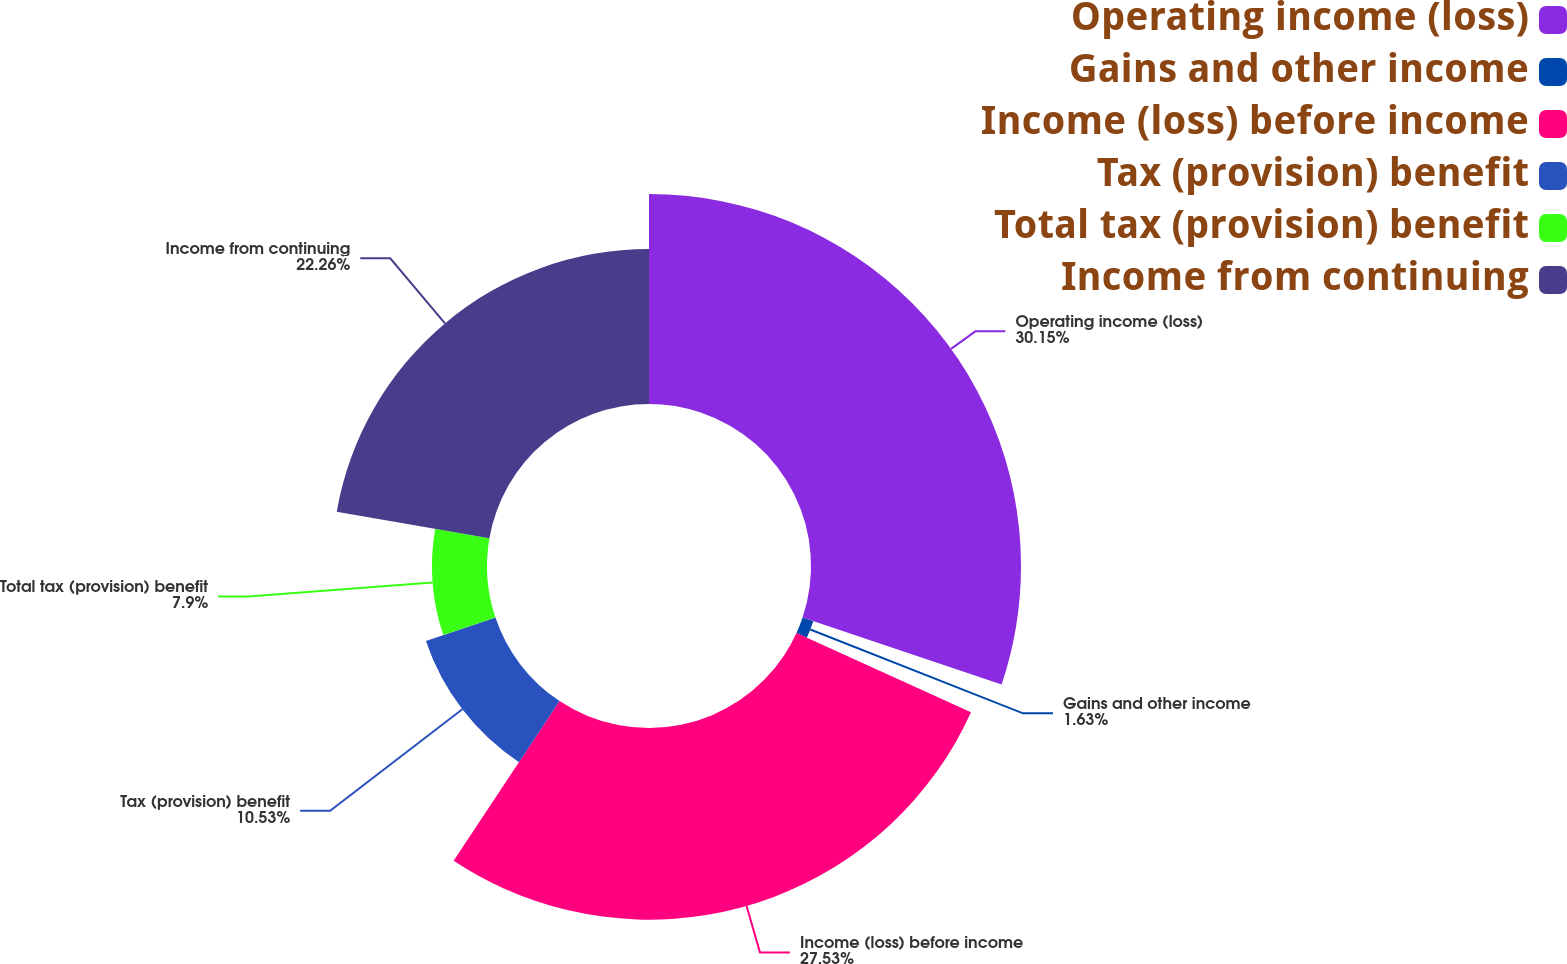<chart> <loc_0><loc_0><loc_500><loc_500><pie_chart><fcel>Operating income (loss)<fcel>Gains and other income<fcel>Income (loss) before income<fcel>Tax (provision) benefit<fcel>Total tax (provision) benefit<fcel>Income from continuing<nl><fcel>30.16%<fcel>1.63%<fcel>27.53%<fcel>10.53%<fcel>7.9%<fcel>22.26%<nl></chart> 